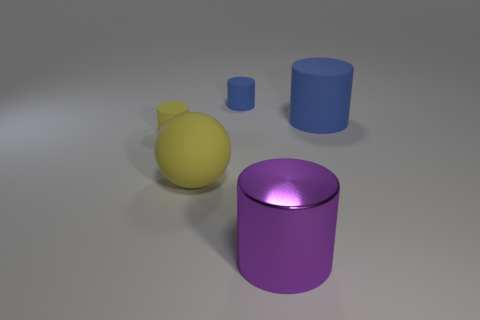Subtract 1 cylinders. How many cylinders are left? 3 Add 1 large red rubber cylinders. How many objects exist? 6 Subtract all red cylinders. Subtract all cyan blocks. How many cylinders are left? 4 Subtract all cylinders. How many objects are left? 1 Add 1 tiny yellow things. How many tiny yellow things exist? 2 Subtract 0 cyan cubes. How many objects are left? 5 Subtract all tiny yellow rubber cylinders. Subtract all large purple cylinders. How many objects are left? 3 Add 5 small blue cylinders. How many small blue cylinders are left? 6 